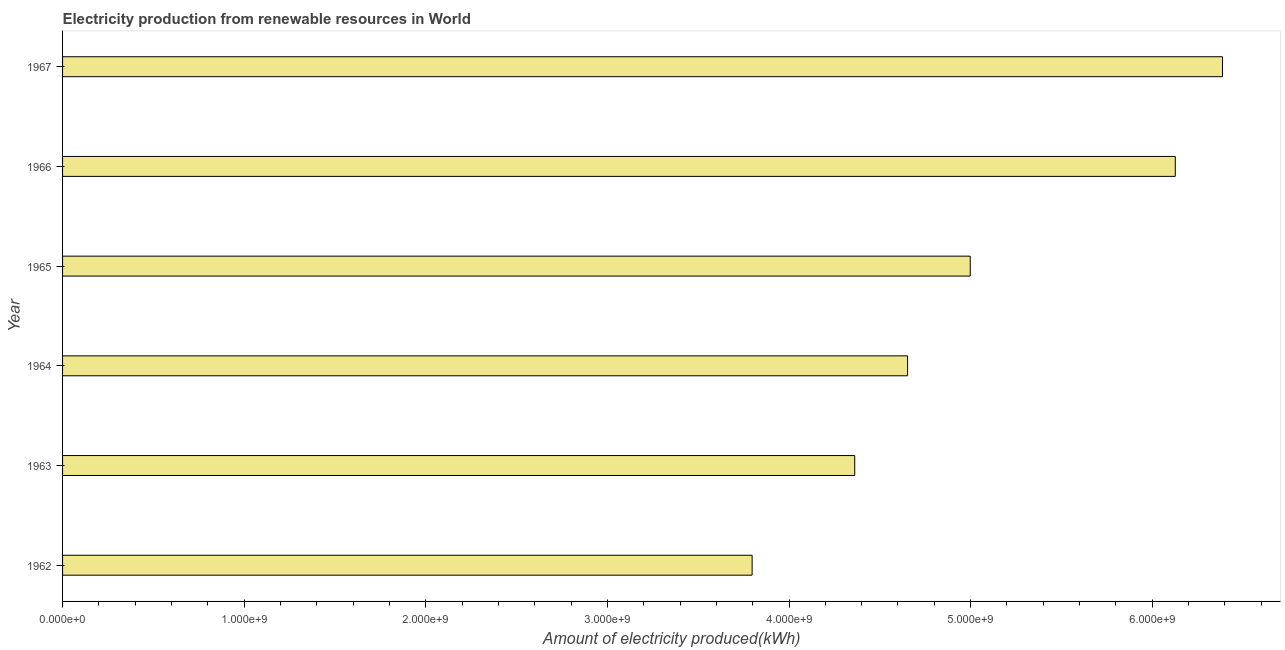Does the graph contain any zero values?
Offer a terse response. No. Does the graph contain grids?
Your response must be concise. No. What is the title of the graph?
Your answer should be compact. Electricity production from renewable resources in World. What is the label or title of the X-axis?
Make the answer very short. Amount of electricity produced(kWh). What is the amount of electricity produced in 1965?
Offer a terse response. 5.00e+09. Across all years, what is the maximum amount of electricity produced?
Your answer should be very brief. 6.39e+09. Across all years, what is the minimum amount of electricity produced?
Offer a terse response. 3.80e+09. In which year was the amount of electricity produced maximum?
Offer a very short reply. 1967. In which year was the amount of electricity produced minimum?
Provide a succinct answer. 1962. What is the sum of the amount of electricity produced?
Keep it short and to the point. 3.03e+1. What is the difference between the amount of electricity produced in 1964 and 1967?
Provide a succinct answer. -1.73e+09. What is the average amount of electricity produced per year?
Offer a terse response. 5.05e+09. What is the median amount of electricity produced?
Your answer should be compact. 4.83e+09. In how many years, is the amount of electricity produced greater than 4600000000 kWh?
Give a very brief answer. 4. Do a majority of the years between 1964 and 1962 (inclusive) have amount of electricity produced greater than 3200000000 kWh?
Offer a very short reply. Yes. What is the ratio of the amount of electricity produced in 1964 to that in 1967?
Your response must be concise. 0.73. Is the amount of electricity produced in 1962 less than that in 1967?
Ensure brevity in your answer.  Yes. What is the difference between the highest and the second highest amount of electricity produced?
Provide a short and direct response. 2.60e+08. Is the sum of the amount of electricity produced in 1962 and 1966 greater than the maximum amount of electricity produced across all years?
Offer a very short reply. Yes. What is the difference between the highest and the lowest amount of electricity produced?
Make the answer very short. 2.59e+09. In how many years, is the amount of electricity produced greater than the average amount of electricity produced taken over all years?
Keep it short and to the point. 2. How many bars are there?
Offer a terse response. 6. How many years are there in the graph?
Your answer should be very brief. 6. Are the values on the major ticks of X-axis written in scientific E-notation?
Provide a succinct answer. Yes. What is the Amount of electricity produced(kWh) of 1962?
Keep it short and to the point. 3.80e+09. What is the Amount of electricity produced(kWh) of 1963?
Your answer should be very brief. 4.36e+09. What is the Amount of electricity produced(kWh) of 1964?
Provide a succinct answer. 4.65e+09. What is the Amount of electricity produced(kWh) in 1965?
Keep it short and to the point. 5.00e+09. What is the Amount of electricity produced(kWh) in 1966?
Your answer should be compact. 6.13e+09. What is the Amount of electricity produced(kWh) in 1967?
Give a very brief answer. 6.39e+09. What is the difference between the Amount of electricity produced(kWh) in 1962 and 1963?
Keep it short and to the point. -5.65e+08. What is the difference between the Amount of electricity produced(kWh) in 1962 and 1964?
Offer a very short reply. -8.56e+08. What is the difference between the Amount of electricity produced(kWh) in 1962 and 1965?
Give a very brief answer. -1.20e+09. What is the difference between the Amount of electricity produced(kWh) in 1962 and 1966?
Offer a terse response. -2.33e+09. What is the difference between the Amount of electricity produced(kWh) in 1962 and 1967?
Your answer should be very brief. -2.59e+09. What is the difference between the Amount of electricity produced(kWh) in 1963 and 1964?
Offer a terse response. -2.91e+08. What is the difference between the Amount of electricity produced(kWh) in 1963 and 1965?
Your answer should be very brief. -6.36e+08. What is the difference between the Amount of electricity produced(kWh) in 1963 and 1966?
Provide a succinct answer. -1.76e+09. What is the difference between the Amount of electricity produced(kWh) in 1963 and 1967?
Provide a short and direct response. -2.02e+09. What is the difference between the Amount of electricity produced(kWh) in 1964 and 1965?
Provide a short and direct response. -3.45e+08. What is the difference between the Amount of electricity produced(kWh) in 1964 and 1966?
Your answer should be compact. -1.47e+09. What is the difference between the Amount of electricity produced(kWh) in 1964 and 1967?
Provide a succinct answer. -1.73e+09. What is the difference between the Amount of electricity produced(kWh) in 1965 and 1966?
Ensure brevity in your answer.  -1.13e+09. What is the difference between the Amount of electricity produced(kWh) in 1965 and 1967?
Your answer should be compact. -1.39e+09. What is the difference between the Amount of electricity produced(kWh) in 1966 and 1967?
Your answer should be very brief. -2.60e+08. What is the ratio of the Amount of electricity produced(kWh) in 1962 to that in 1963?
Provide a short and direct response. 0.87. What is the ratio of the Amount of electricity produced(kWh) in 1962 to that in 1964?
Keep it short and to the point. 0.82. What is the ratio of the Amount of electricity produced(kWh) in 1962 to that in 1965?
Offer a terse response. 0.76. What is the ratio of the Amount of electricity produced(kWh) in 1962 to that in 1966?
Give a very brief answer. 0.62. What is the ratio of the Amount of electricity produced(kWh) in 1962 to that in 1967?
Offer a terse response. 0.59. What is the ratio of the Amount of electricity produced(kWh) in 1963 to that in 1964?
Ensure brevity in your answer.  0.94. What is the ratio of the Amount of electricity produced(kWh) in 1963 to that in 1965?
Provide a succinct answer. 0.87. What is the ratio of the Amount of electricity produced(kWh) in 1963 to that in 1966?
Give a very brief answer. 0.71. What is the ratio of the Amount of electricity produced(kWh) in 1963 to that in 1967?
Make the answer very short. 0.68. What is the ratio of the Amount of electricity produced(kWh) in 1964 to that in 1966?
Provide a succinct answer. 0.76. What is the ratio of the Amount of electricity produced(kWh) in 1964 to that in 1967?
Make the answer very short. 0.73. What is the ratio of the Amount of electricity produced(kWh) in 1965 to that in 1966?
Make the answer very short. 0.82. What is the ratio of the Amount of electricity produced(kWh) in 1965 to that in 1967?
Provide a short and direct response. 0.78. What is the ratio of the Amount of electricity produced(kWh) in 1966 to that in 1967?
Your answer should be compact. 0.96. 